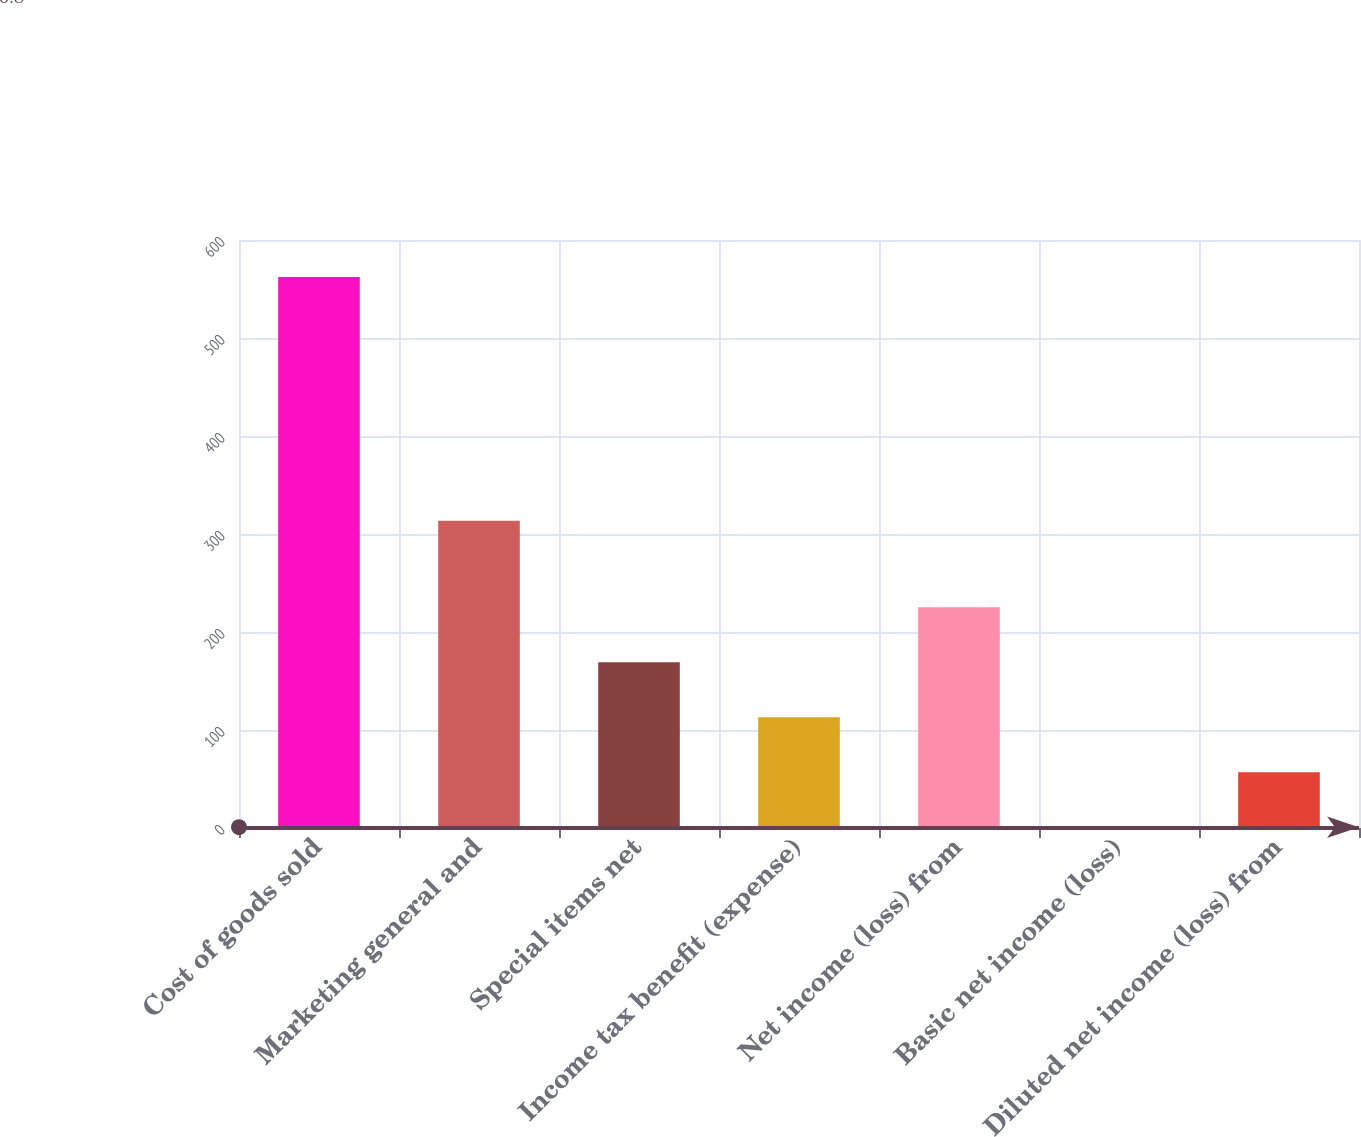Convert chart. <chart><loc_0><loc_0><loc_500><loc_500><bar_chart><fcel>Cost of goods sold<fcel>Marketing general and<fcel>Special items net<fcel>Income tax benefit (expense)<fcel>Net income (loss) from<fcel>Basic net income (loss)<fcel>Diluted net income (loss) from<nl><fcel>562.2<fcel>313.6<fcel>169.22<fcel>113.08<fcel>225.36<fcel>0.8<fcel>56.94<nl></chart> 